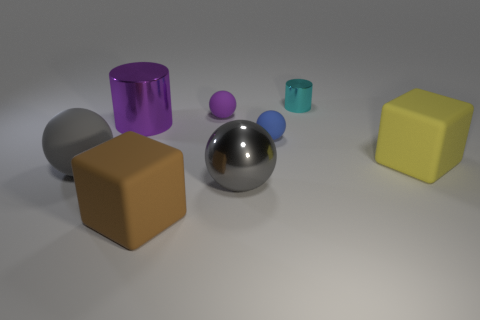How many other things are there of the same material as the brown thing?
Ensure brevity in your answer.  4. Do the large metal object that is behind the gray rubber object and the big gray thing that is on the right side of the small purple object have the same shape?
Make the answer very short. No. Is the small blue sphere made of the same material as the large brown block?
Give a very brief answer. Yes. How big is the matte cube that is right of the large block that is to the left of the tiny matte object behind the tiny blue matte ball?
Offer a terse response. Large. How many other things are there of the same color as the metallic ball?
Keep it short and to the point. 1. What shape is the brown rubber object that is the same size as the purple cylinder?
Offer a very short reply. Cube. What number of large things are either yellow cubes or purple metal objects?
Your answer should be compact. 2. There is a block on the left side of the block that is right of the brown cube; is there a rubber ball to the right of it?
Make the answer very short. Yes. Is there a cyan metallic block of the same size as the blue rubber thing?
Your answer should be compact. No. There is a blue ball that is the same size as the purple matte object; what is its material?
Ensure brevity in your answer.  Rubber. 